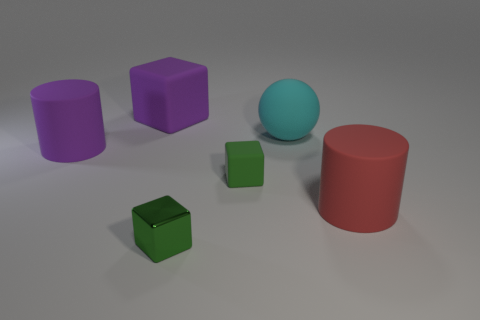Is there a small green rubber cube that is behind the tiny cube that is on the left side of the tiny green rubber thing?
Provide a succinct answer. Yes. What number of big purple matte things are there?
Your answer should be very brief. 2. The big thing that is both in front of the cyan rubber sphere and to the left of the small green shiny thing is what color?
Your answer should be very brief. Purple. There is a purple object that is the same shape as the large red rubber thing; what is its size?
Your answer should be very brief. Large. How many cyan matte objects are the same size as the purple rubber block?
Your response must be concise. 1. What is the big purple cube made of?
Your response must be concise. Rubber. Are there any large purple cylinders in front of the green rubber thing?
Give a very brief answer. No. There is a cyan thing that is the same material as the red thing; what is its size?
Your answer should be very brief. Large. How many things are the same color as the small rubber cube?
Offer a very short reply. 1. Is the number of large purple objects that are on the left side of the metallic thing less than the number of big red matte cylinders that are left of the large cyan sphere?
Give a very brief answer. No. 